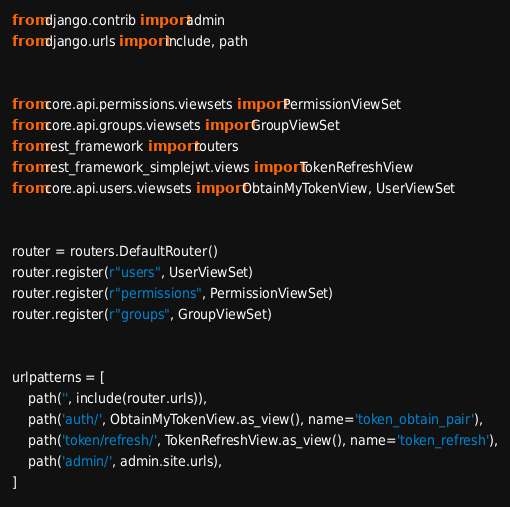Convert code to text. <code><loc_0><loc_0><loc_500><loc_500><_Python_>
from django.contrib import admin
from django.urls import include, path


from core.api.permissions.viewsets import PermissionViewSet
from core.api.groups.viewsets import GroupViewSet
from rest_framework import routers
from rest_framework_simplejwt.views import TokenRefreshView
from core.api.users.viewsets import ObtainMyTokenView, UserViewSet


router = routers.DefaultRouter()
router.register(r"users", UserViewSet)
router.register(r"permissions", PermissionViewSet)
router.register(r"groups", GroupViewSet)


urlpatterns = [
    path('', include(router.urls)),
    path('auth/', ObtainMyTokenView.as_view(), name='token_obtain_pair'),
    path('token/refresh/', TokenRefreshView.as_view(), name='token_refresh'),
    path('admin/', admin.site.urls),
]
</code> 